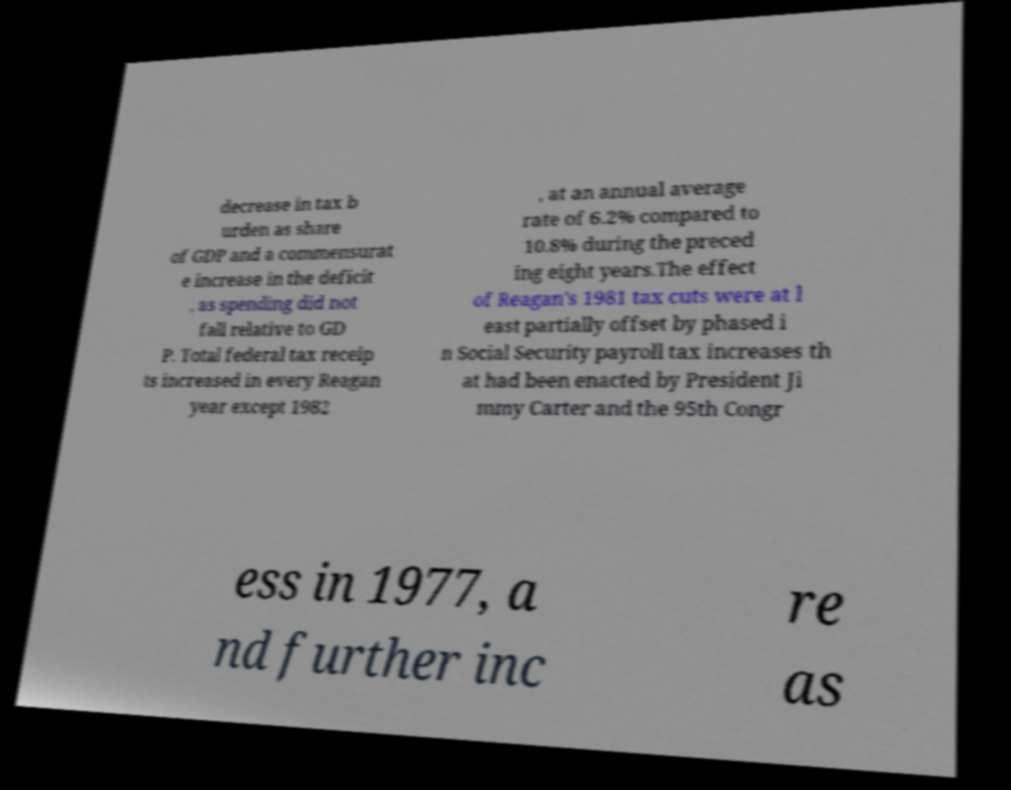Could you extract and type out the text from this image? decrease in tax b urden as share of GDP and a commensurat e increase in the deficit , as spending did not fall relative to GD P. Total federal tax receip ts increased in every Reagan year except 1982 , at an annual average rate of 6.2% compared to 10.8% during the preced ing eight years.The effect of Reagan's 1981 tax cuts were at l east partially offset by phased i n Social Security payroll tax increases th at had been enacted by President Ji mmy Carter and the 95th Congr ess in 1977, a nd further inc re as 